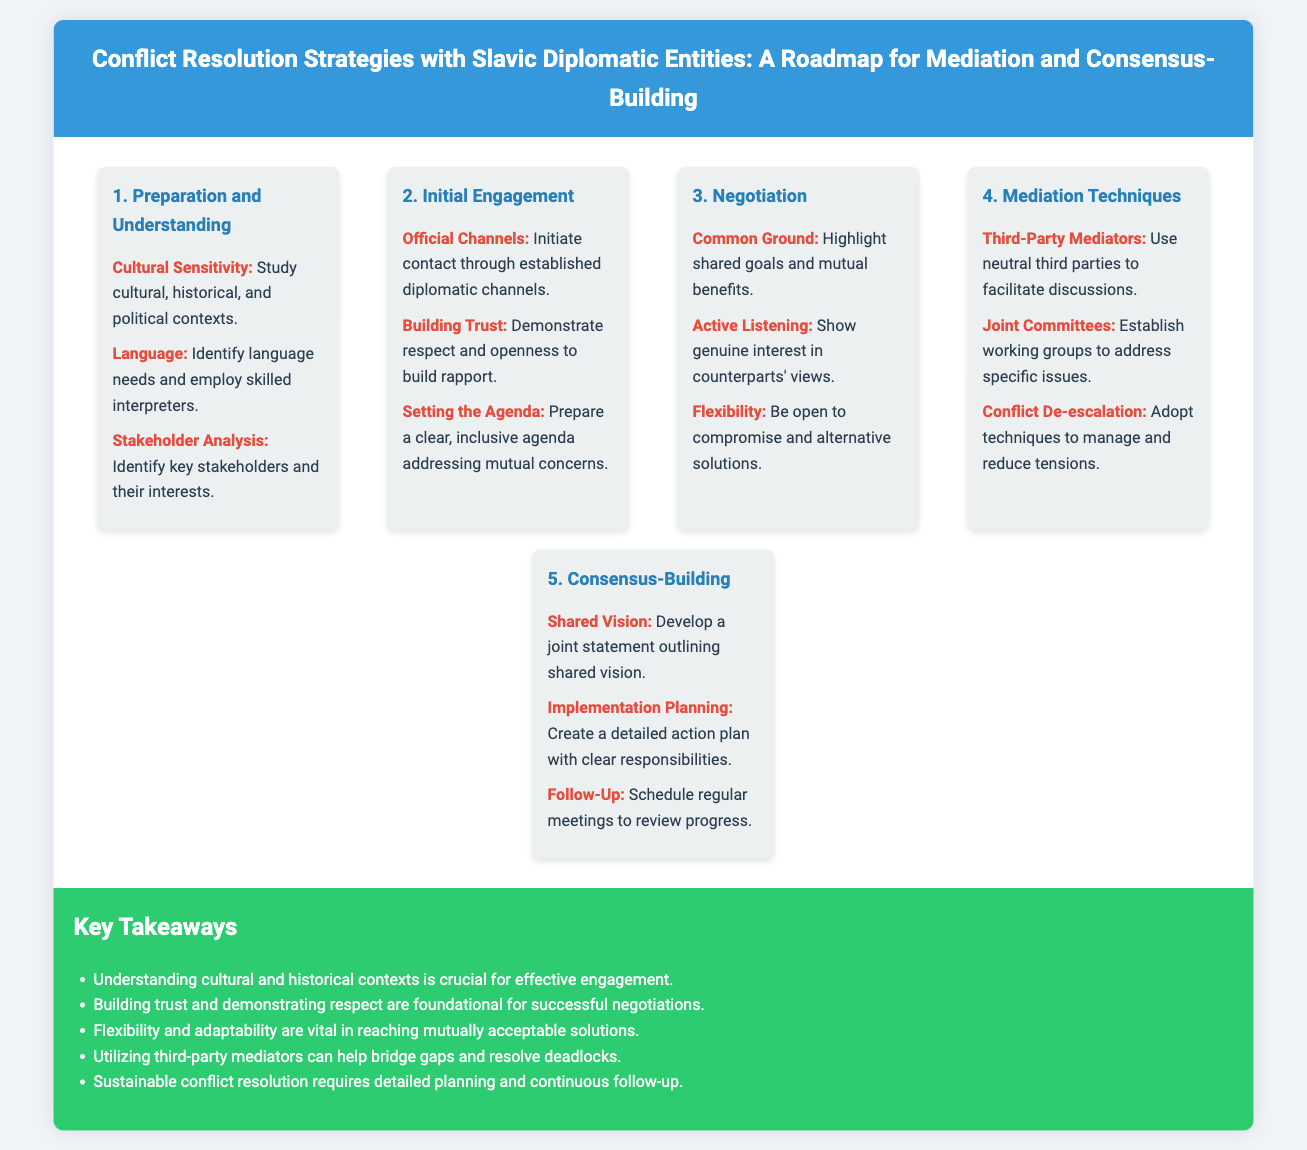what is the first step in the conflict resolution process? The first step outlined in the process is "Preparation and Understanding."
Answer: Preparation and Understanding what should be studied in the first step? In the first step, it is important to study cultural, historical, and political contexts.
Answer: Cultural, historical, and political contexts which technique involves using neutral third parties? The technique that involves using neutral third parties is referred to as "Third-Party Mediators."
Answer: Third-Party Mediators how many aspects are there in the "Consensus-Building" step? There are three aspects presented in the "Consensus-Building" step.
Answer: Three what is emphasized as crucial for effective engagement? The document emphasizes that understanding cultural and historical contexts is crucial for effective engagement.
Answer: Understanding cultural and historical contexts what is the focus of the "Negotiation" step? The focus of the "Negotiation" step is on highlighting shared goals and mutual benefits.
Answer: Highlighting shared goals and mutual benefits which aspect involves creating a detailed action plan? The aspect that involves creating a detailed action plan is titled "Implementation Planning."
Answer: Implementation Planning how many key takeaways are listed in the conclusion? There are five key takeaways listed in the conclusion.
Answer: Five 